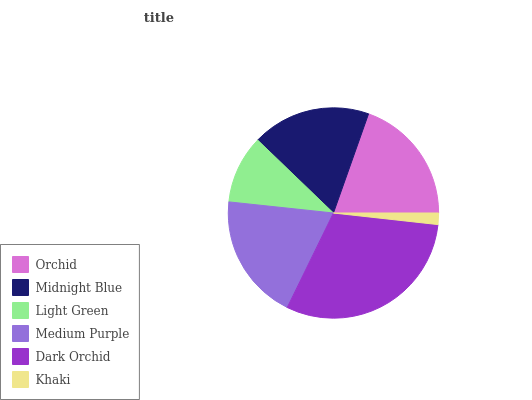Is Khaki the minimum?
Answer yes or no. Yes. Is Dark Orchid the maximum?
Answer yes or no. Yes. Is Midnight Blue the minimum?
Answer yes or no. No. Is Midnight Blue the maximum?
Answer yes or no. No. Is Orchid greater than Midnight Blue?
Answer yes or no. Yes. Is Midnight Blue less than Orchid?
Answer yes or no. Yes. Is Midnight Blue greater than Orchid?
Answer yes or no. No. Is Orchid less than Midnight Blue?
Answer yes or no. No. Is Medium Purple the high median?
Answer yes or no. Yes. Is Midnight Blue the low median?
Answer yes or no. Yes. Is Light Green the high median?
Answer yes or no. No. Is Khaki the low median?
Answer yes or no. No. 